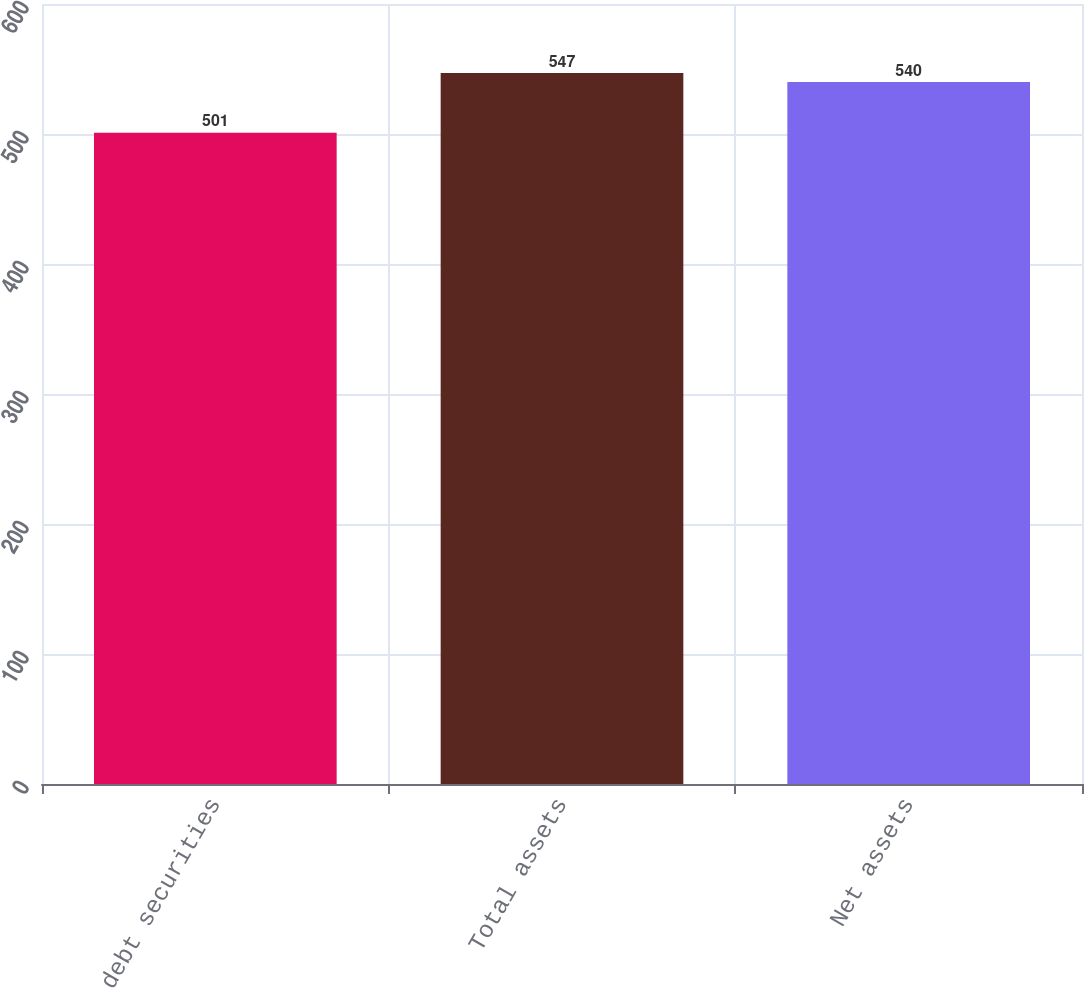Convert chart. <chart><loc_0><loc_0><loc_500><loc_500><bar_chart><fcel>NDTF debt securities<fcel>Total assets<fcel>Net assets<nl><fcel>501<fcel>547<fcel>540<nl></chart> 